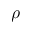Convert formula to latex. <formula><loc_0><loc_0><loc_500><loc_500>\rho</formula> 